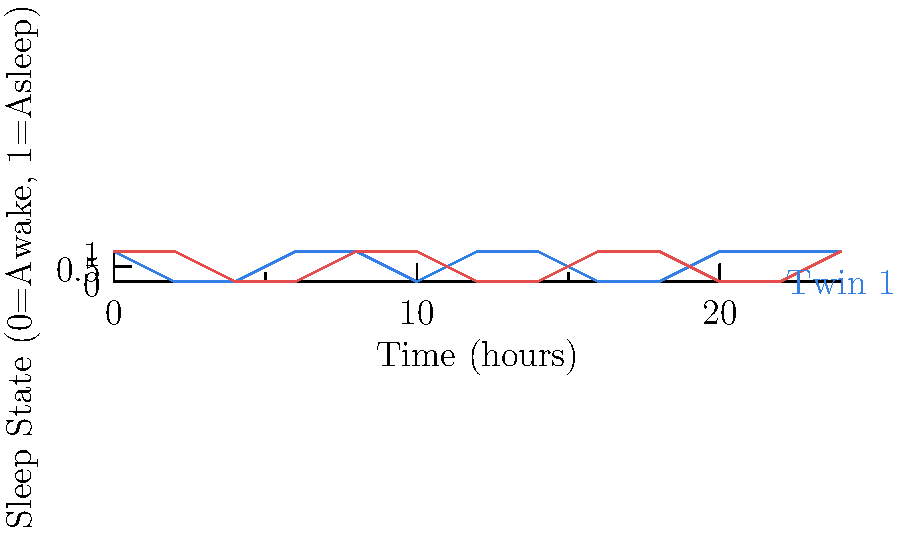Based on the sleep schedule chart for twins, what is the optimal time range for scheduling a synchronized nap for both twins? To determine the optimal time range for a synchronized nap, we need to follow these steps:

1. Identify periods when both twins are asleep (both lines at 1 on the y-axis).
2. Look for the longest continuous period where both twins are asleep.
3. Consider the practical aspects of nap scheduling.

Analyzing the chart:
- Twin 1 (blue +) sleep periods: 0-2, 6-8, 12-14, 20-24
- Twin 2 (red *) sleep periods: 0-4, 8-12, 16-20, 22-24

Overlapping sleep periods:
- 0-2 hours
- 8-10 hours
- 22-24 hours

The longest continuous overlapping period is 2 hours. Among the three options, 8-10 hours is the most practical for a daytime nap.

Therefore, the optimal time range for scheduling a synchronized nap for both twins is 8-10 hours (or 8:00 AM to 10:00 AM if we assume the chart starts at midnight).
Answer: 8-10 hours 